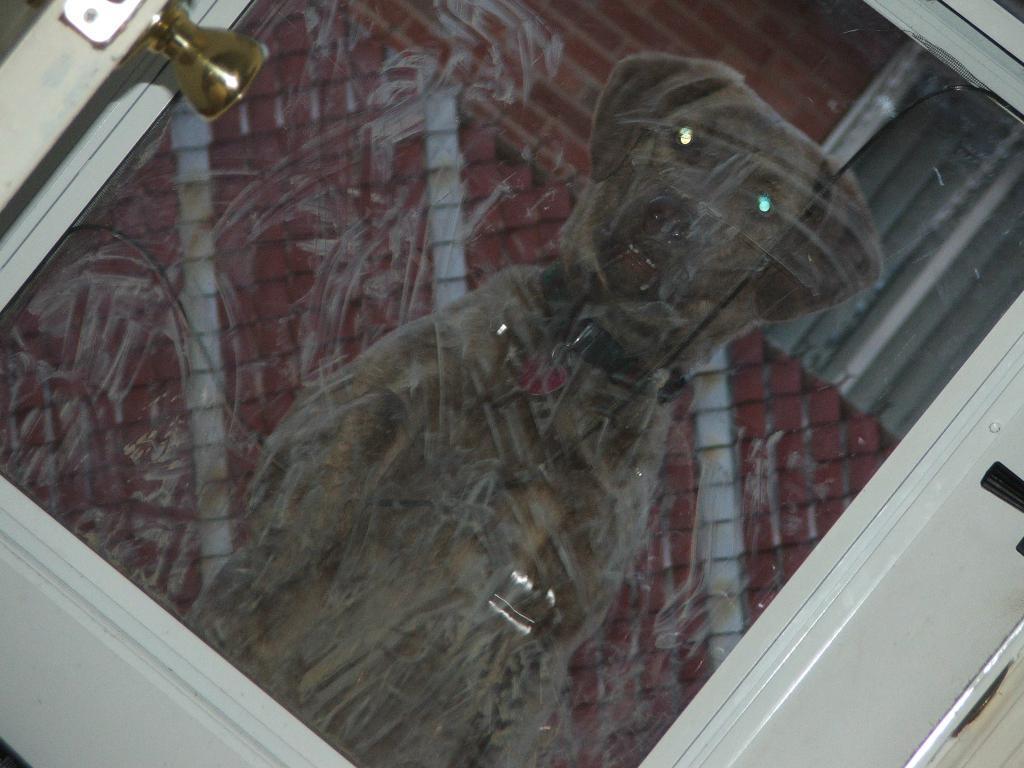Could you give a brief overview of what you see in this image? In this image we can see a door with a glass pane. On that there is reflection of dog and some other objects. 